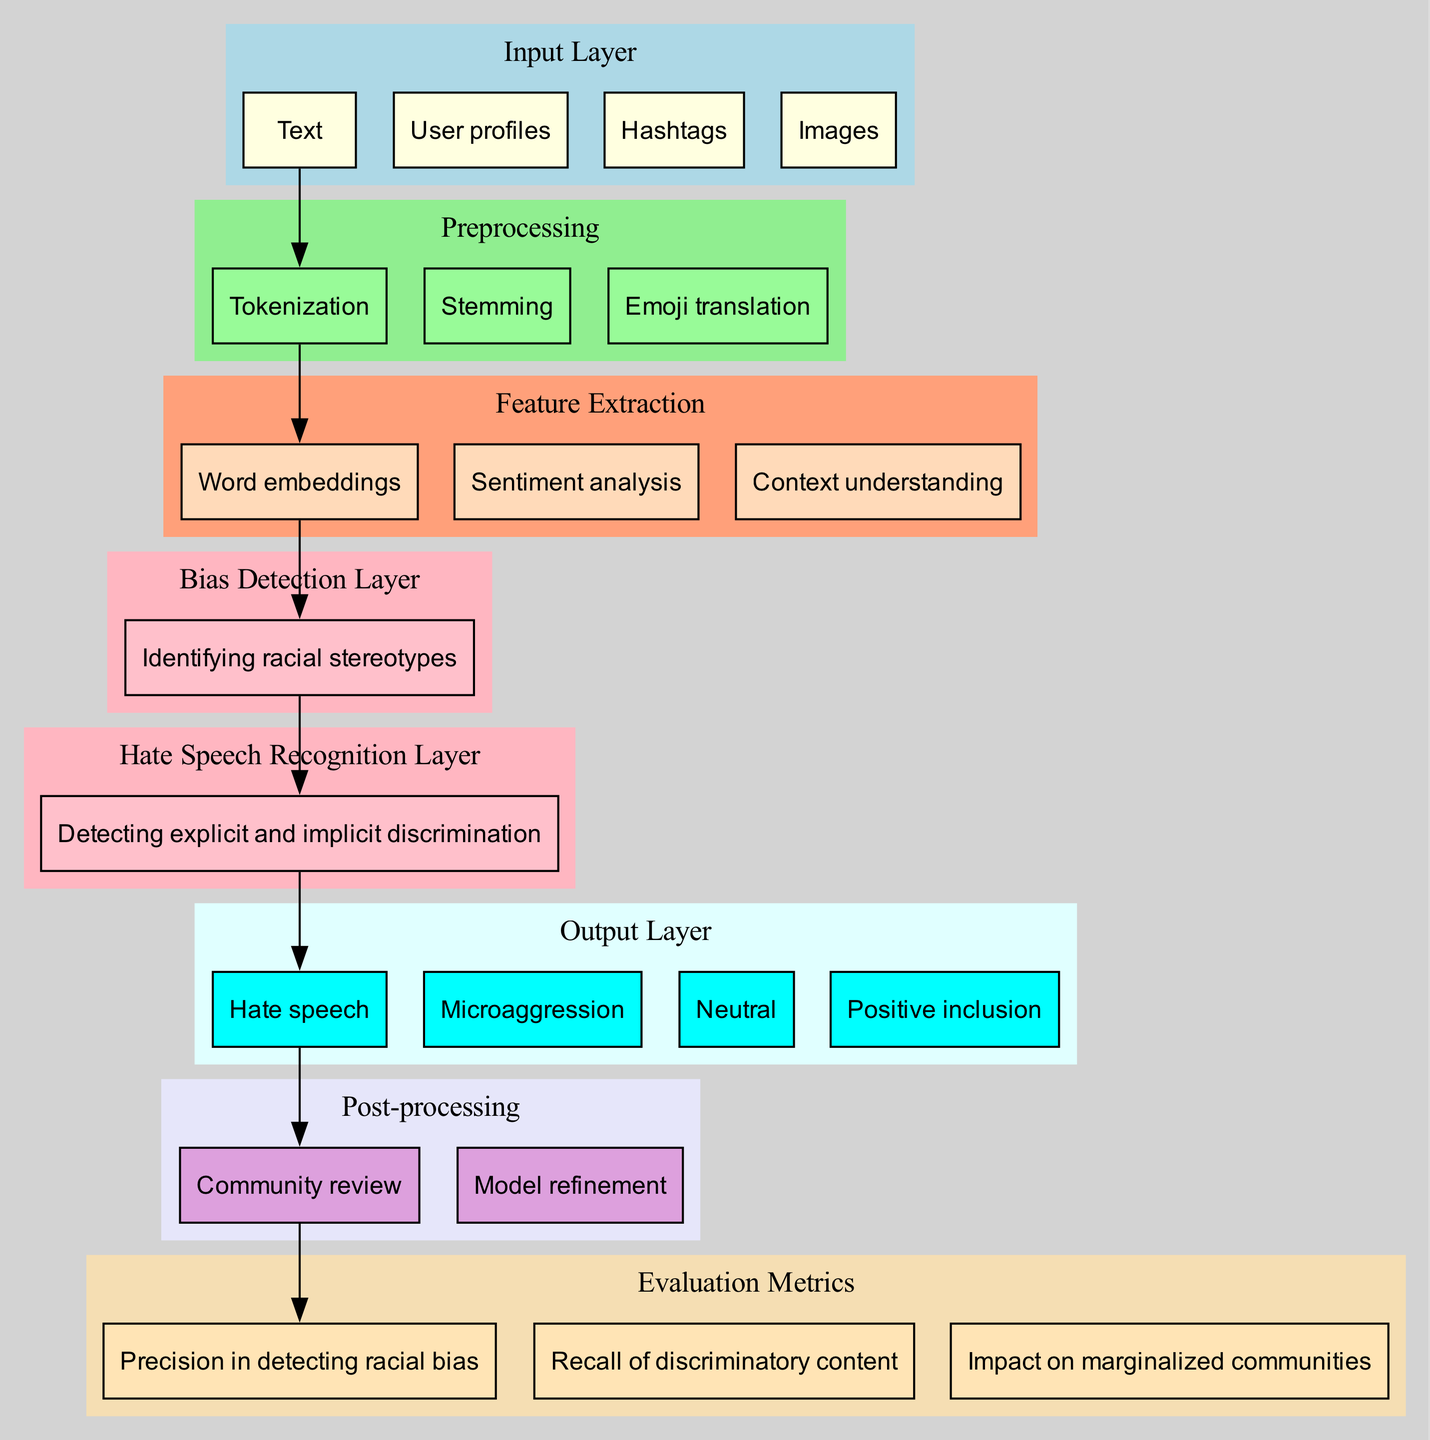What is the first component of the input layer? The first component listed under the input layer is "Text." It is mentioned directly in the data description provided.
Answer: Text How many main steps are involved in the preprocessing? The data specifies three steps within the preprocessing section: Tokenization, Stemming, and Emoji translation. Thus, the total is three.
Answer: 3 What technique is used for sentiment analysis in feature extraction? Sentiment analysis is identified as one of the techniques within the feature extraction section, explicitly mentioned in the data provided.
Answer: Sentiment analysis Which layer focuses on detecting explicit and implicit discrimination? The layer that focuses on this task is called the "Hate Speech Recognition Layer," as stated in the hidden layers section of the data.
Answer: Hate Speech Recognition Layer What action comes after 'Community review' in the post-processing phase? The action that follows 'Community review' in the diagram is 'Model refinement.' This order is clearly outlined in the post-processing section.
Answer: Model refinement How many evaluation metrics are listed in the diagram? The evaluation metrics section contains three specific metrics, which can be counted directly from the provided data.
Answer: 3 What output category is used for detecting microaggressions? The output category for detecting microaggressions is explicitly listed as "Microaggression." This classification is part of the output layer details in the data.
Answer: Microaggression What is the focus of the "Bias Detection Layer"? The "Bias Detection Layer" has a focus on "Identifying racial stereotypes," which directly describes its specific aim in the neural network.
Answer: Identifying racial stereotypes Which input component connects to the first preprocessing step? The component that connects to the first step (Tokenization) is "Text," as indicated by the directional lines outlined in the diagram's flow.
Answer: Text 